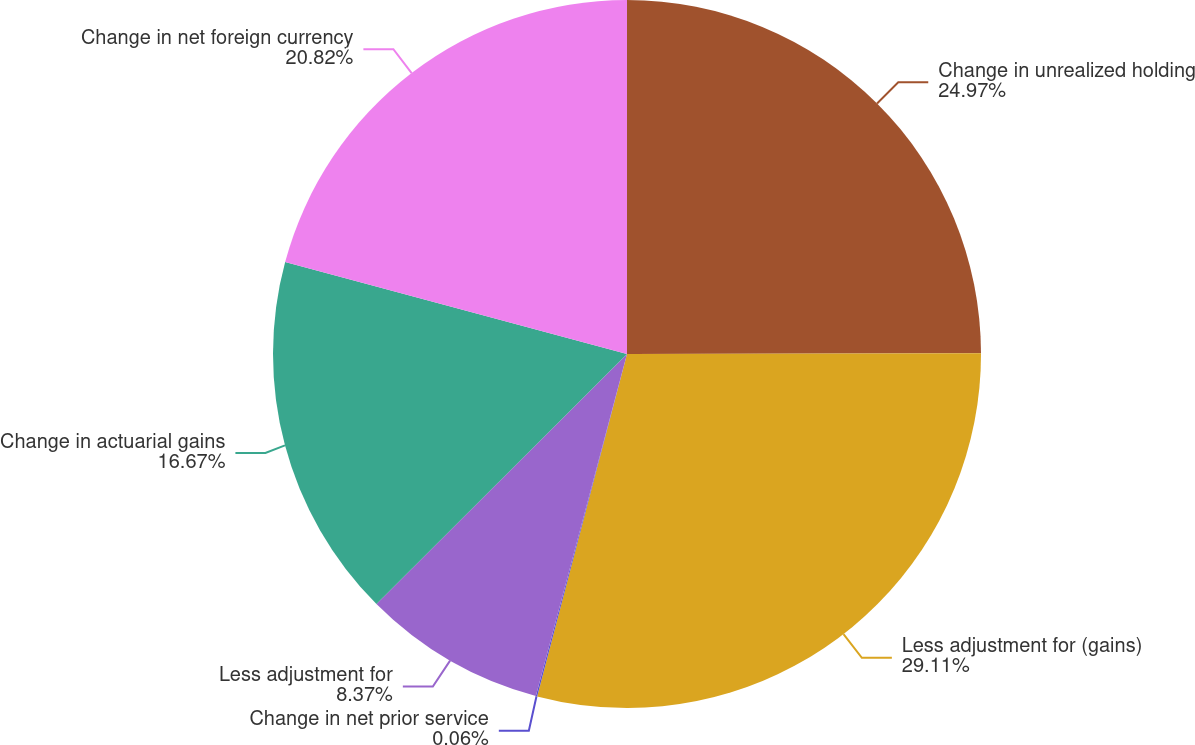Convert chart to OTSL. <chart><loc_0><loc_0><loc_500><loc_500><pie_chart><fcel>Change in unrealized holding<fcel>Less adjustment for (gains)<fcel>Change in net prior service<fcel>Less adjustment for<fcel>Change in actuarial gains<fcel>Change in net foreign currency<nl><fcel>24.97%<fcel>29.12%<fcel>0.06%<fcel>8.37%<fcel>16.67%<fcel>20.82%<nl></chart> 